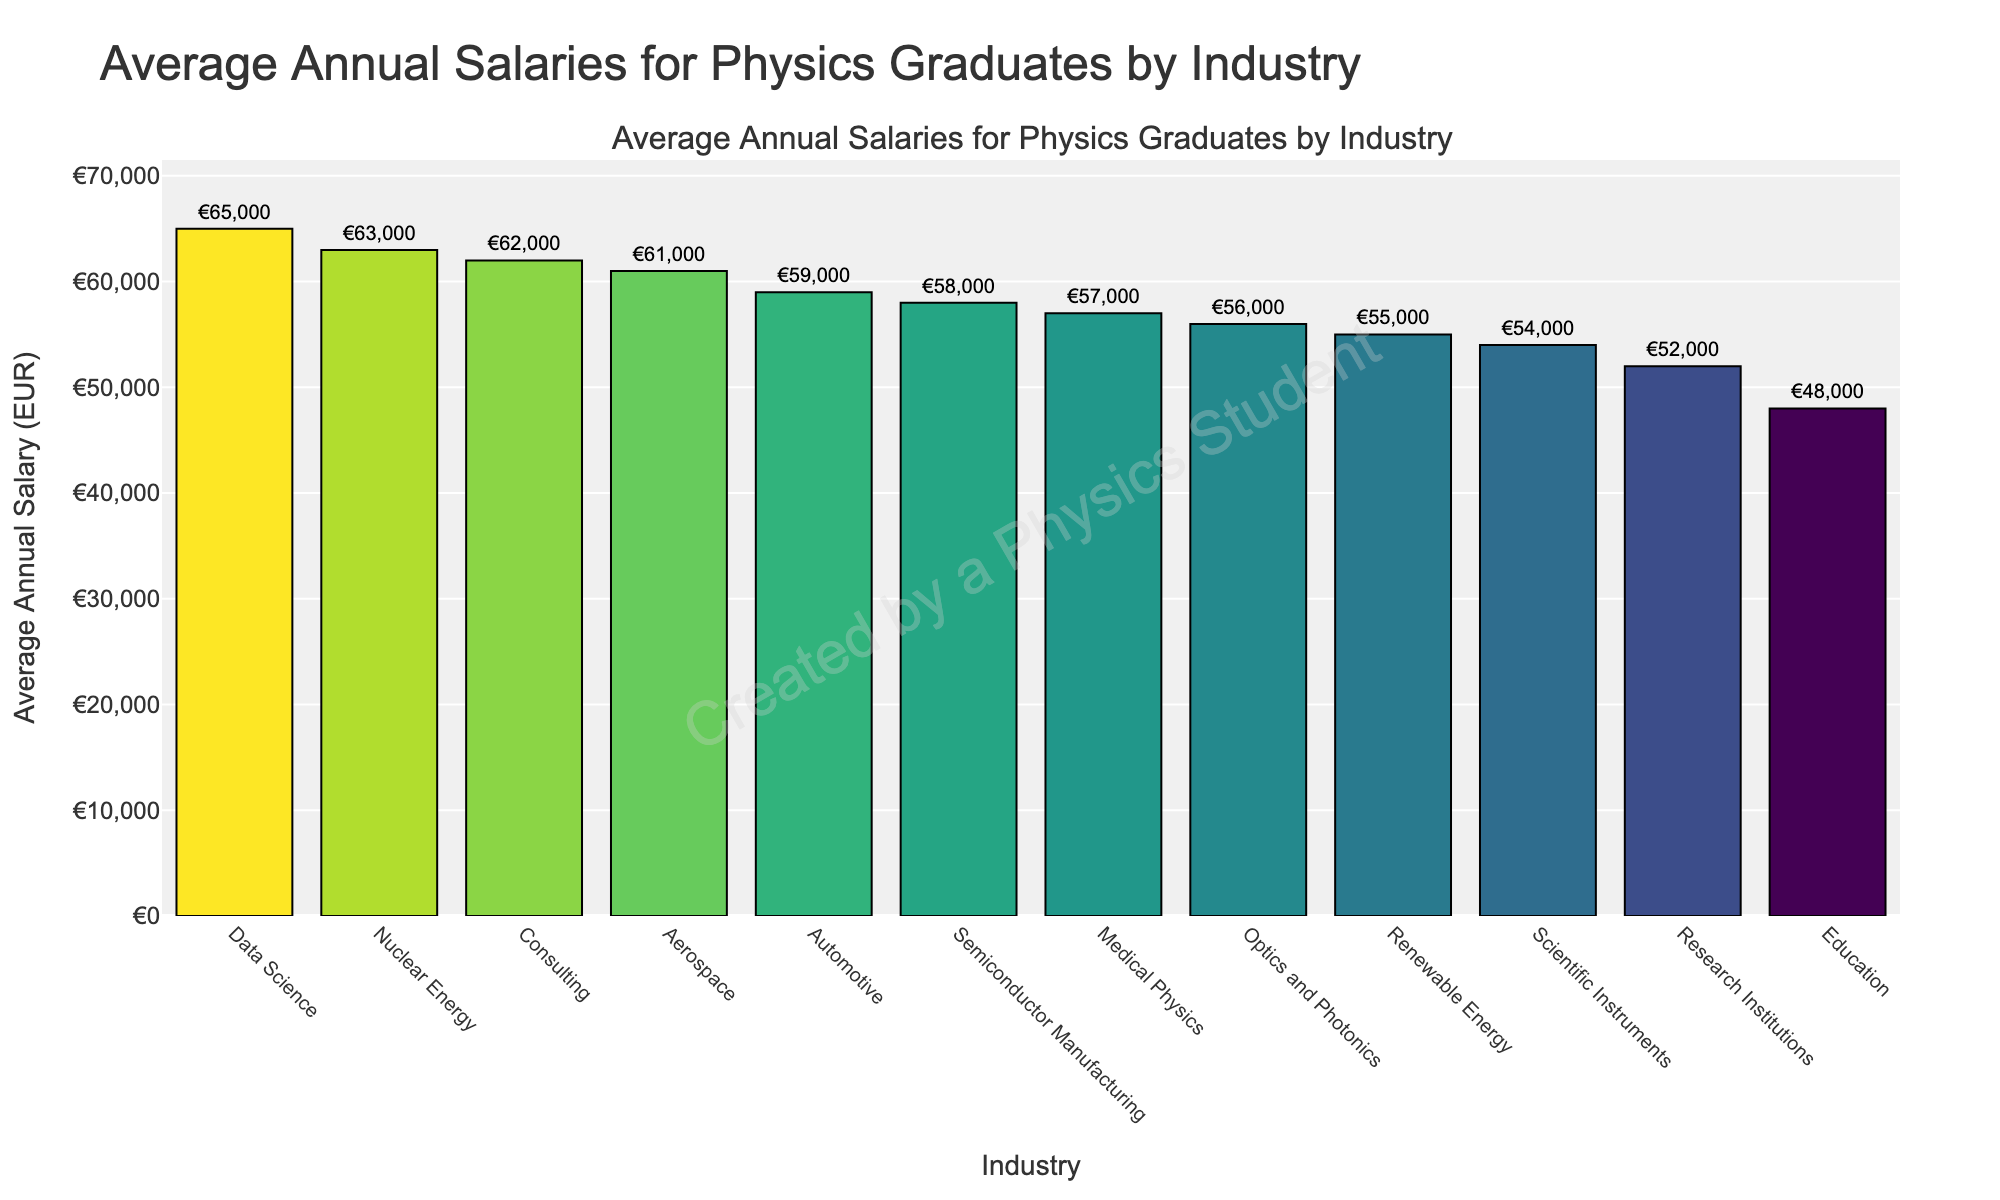What industry has the highest average annual salary for physics graduates? By examining the tallest bar and confirming the industry label, we see that Data Science has the highest salary.
Answer: Data Science Which industry has a higher average annual salary: Nuclear Energy or Medical Physics? Comparing the bar heights and labels of Nuclear Energy and Medical Physics, we see that the average salary for Nuclear Energy (63,000 EUR) is higher than Medical Physics (57,000 EUR).
Answer: Nuclear Energy What is the difference in average annual salaries between Aerospace and Education? Aerospace has an average salary of 61,000 EUR, and Education has 48,000 EUR. The difference is calculated as 61,000 - 48,000 = 13,000 EUR.
Answer: 13,000 EUR Which industry is closest in average annual salary to Renewable Energy? By visually inspecting bars near the Renewable Energy bar, we find that Medical Physics is closest with a salary of 57,000 EUR compared to Renewable Energy's 55,000 EUR.
Answer: Medical Physics What are the three industries with the lowest average annual salaries? Sorting by the shortest bars, the industries with the lowest salaries are Education (48,000 EUR), Research Institutions (52,000 EUR), and Scientific Instruments (54,000 EUR).
Answer: Education, Research Institutions, Scientific Instruments How do the average annual salaries of Automotive and Consulting compare? Comparing bar heights, Automotive has 59,000 EUR while Consulting has 62,000 EUR. Consulting has a higher salary.
Answer: Consulting What is the average salary difference between the top three highest-paying industries and the bottom three lowest-paying industries? The top three are Data Science (65,000 EUR), Nuclear Energy (63,000 EUR), and Consulting (62,000 EUR). The bottom three are Education (48,000 EUR), Research Institutions (52,000 EUR), and Scientific Instruments (54,000 EUR). Average salary for top three: (65,000 + 63,000 + 62,000) / 3 = 63,333.33 EUR. Average salary for bottom three: (48,000 + 52,000 + 54,000) / 3 = 51,333.33 EUR. Difference: 63,333.33 - 51,333.33 = 12,000 EUR.
Answer: 12,000 EUR What industry has an average salary closest to the overall average salary of all industries listed? Calculate the overall average salary: (52000 + 61000 + 58000 + 55000 + 59000 + 65000 + 57000 + 63000 + 56000 + 54000 + 62000 + 48000) / 12 = 57,333.33 EUR. The industry closest to 57,333.33 EUR is Medical Physics with 57,000 EUR.
Answer: Medical Physics How much higher is the average annual salary in Data Science compared to Semiconductor Manufacturing? Data Science has 65,000 EUR, Semiconductor Manufacturing has 58,000 EUR. The difference is calculated as 65,000 - 58,000 = 7,000 EUR.
Answer: 7,000 EUR 